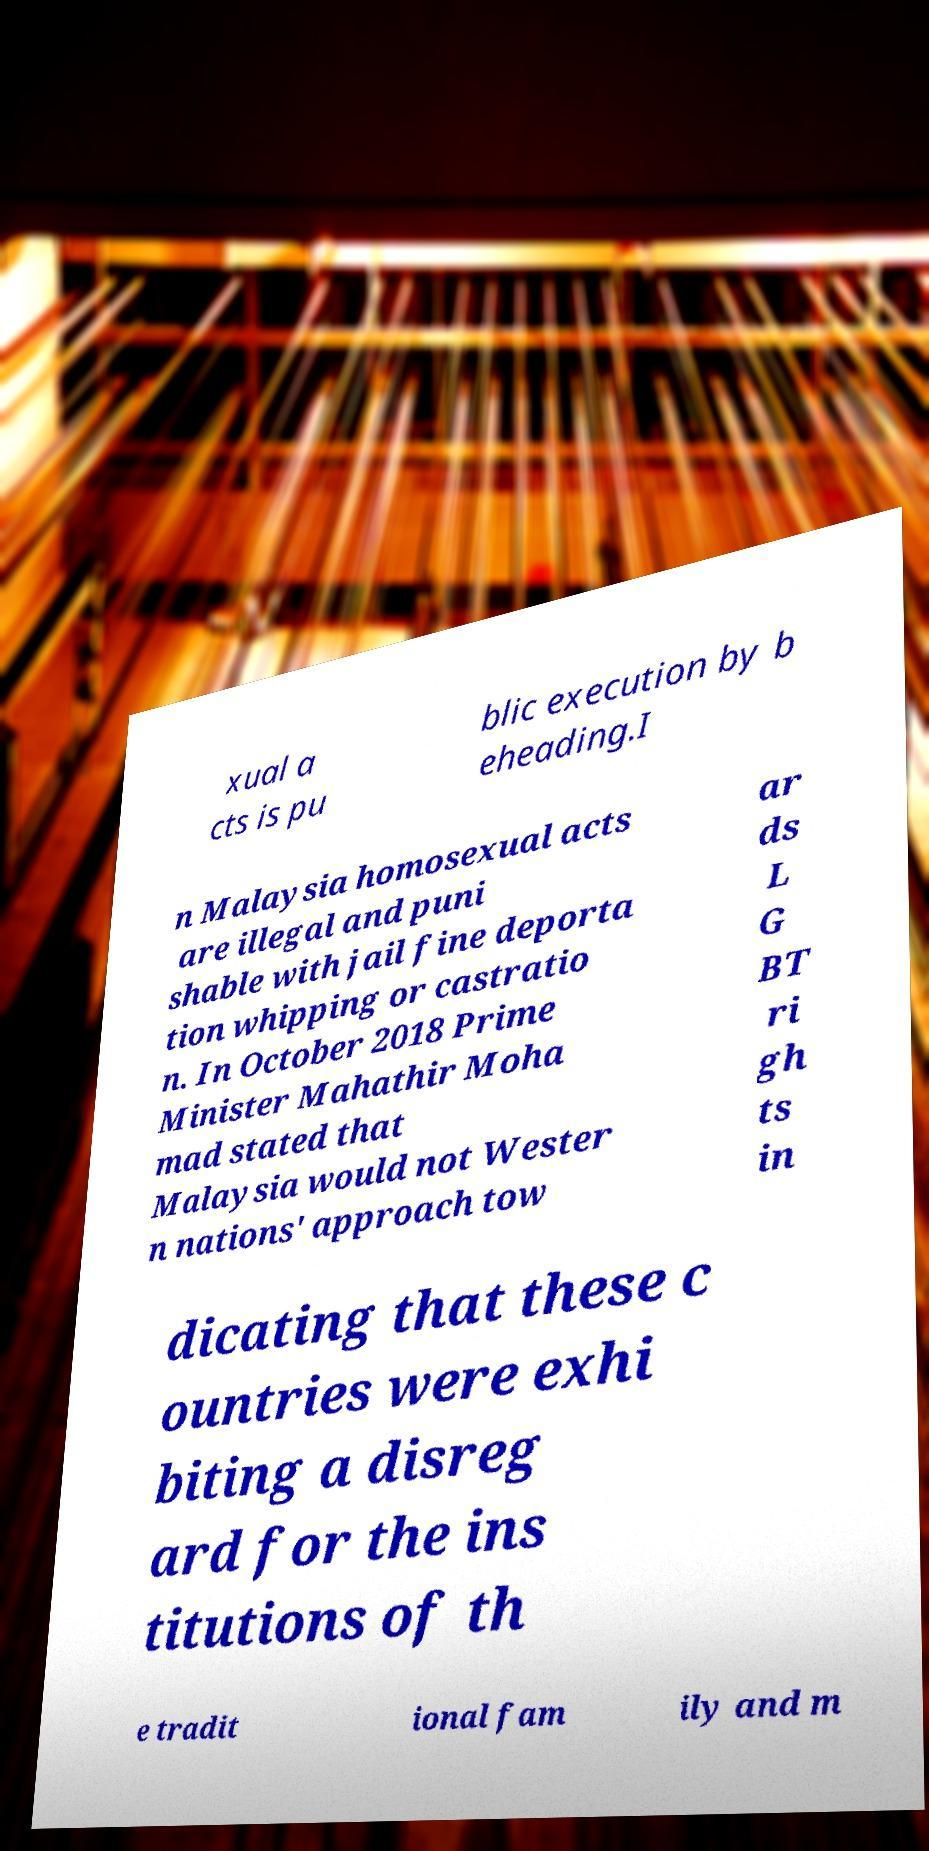Could you extract and type out the text from this image? xual a cts is pu blic execution by b eheading.I n Malaysia homosexual acts are illegal and puni shable with jail fine deporta tion whipping or castratio n. In October 2018 Prime Minister Mahathir Moha mad stated that Malaysia would not Wester n nations' approach tow ar ds L G BT ri gh ts in dicating that these c ountries were exhi biting a disreg ard for the ins titutions of th e tradit ional fam ily and m 